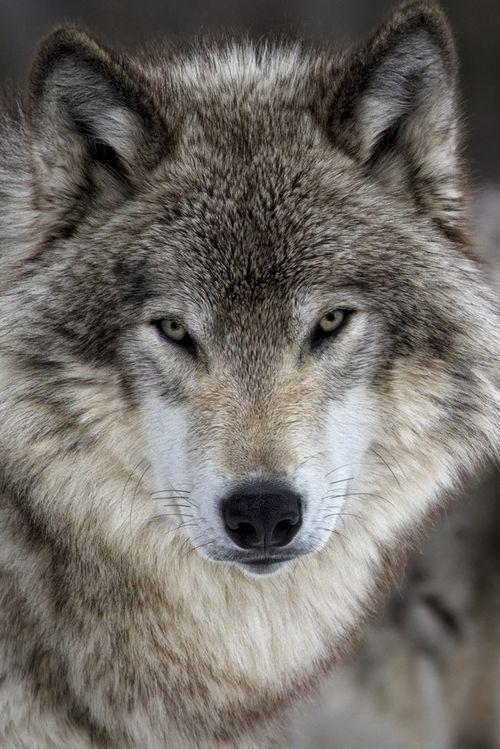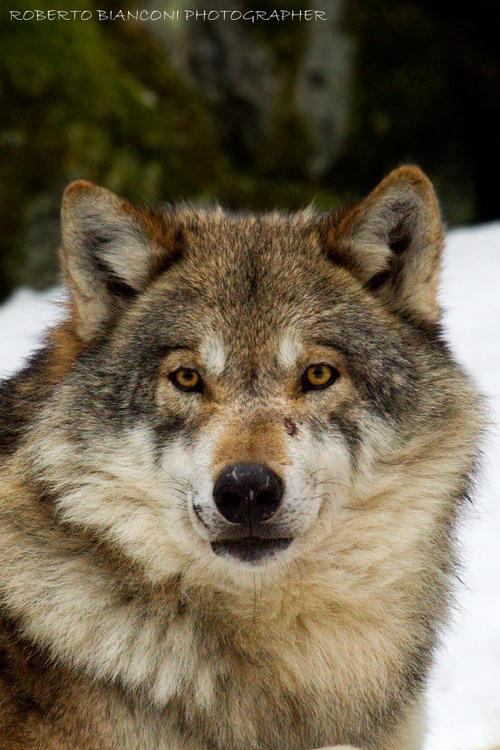The first image is the image on the left, the second image is the image on the right. Assess this claim about the two images: "There is at least one wolf with over 80% white and yellow fur covering their face.". Correct or not? Answer yes or no. No. The first image is the image on the left, the second image is the image on the right. Analyze the images presented: Is the assertion "profile of wolves faces only facing the camera" valid? Answer yes or no. Yes. 